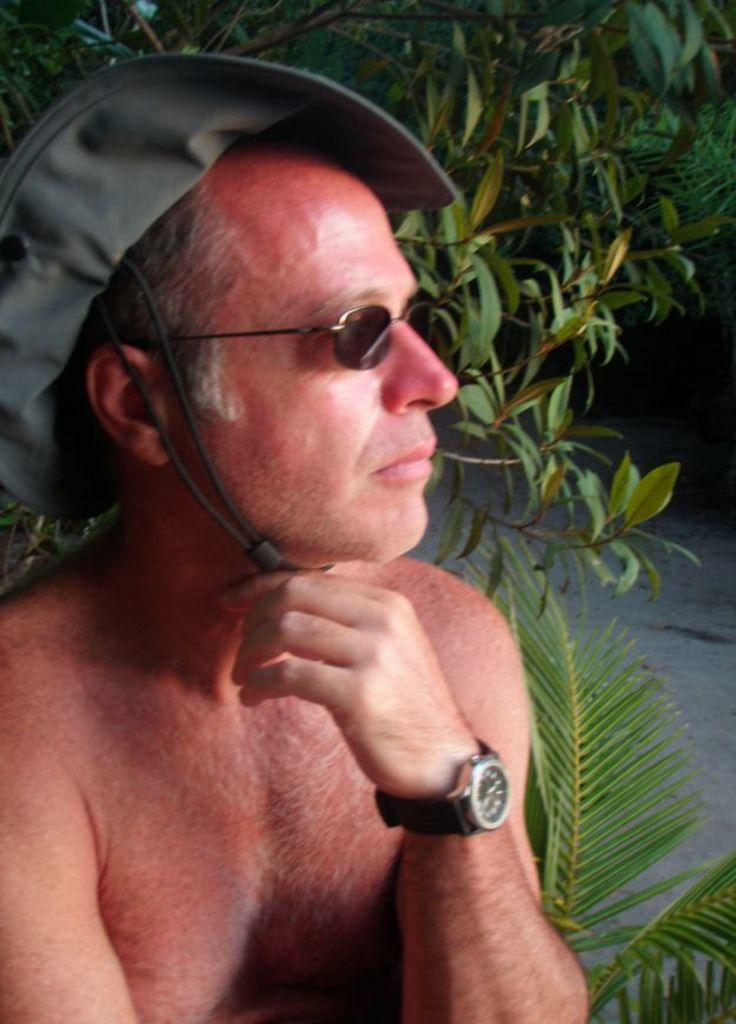What can be seen in the image? There is a person in the image. What accessories is the person wearing? The person is wearing a watch, goggles, and a hat. What is the background of the image? There are trees in the background of the image. What is the color of the trees? The trees are green in color. What type of property is being sold in the image? There is no property being sold in the image; it features a person wearing a watch, goggles, and a hat, with trees in the background. Is there a knife visible in the image? No, there is no knife present in the image. 